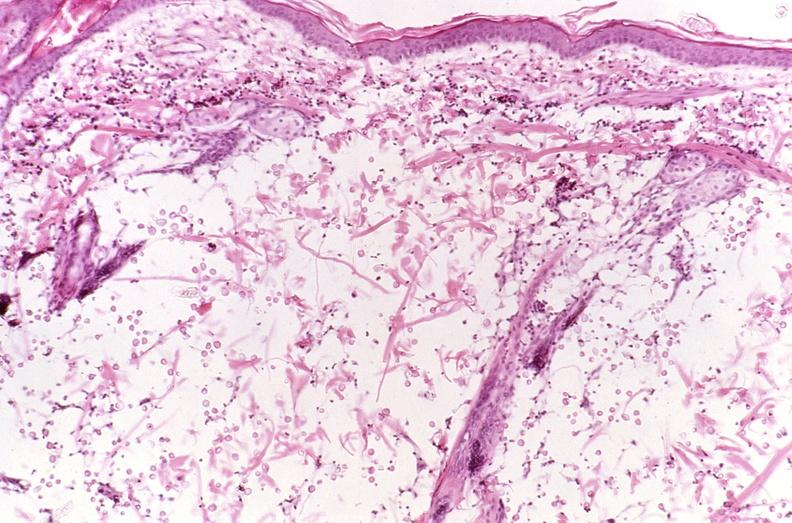does this image show cryptococcal dematitis?
Answer the question using a single word or phrase. Yes 